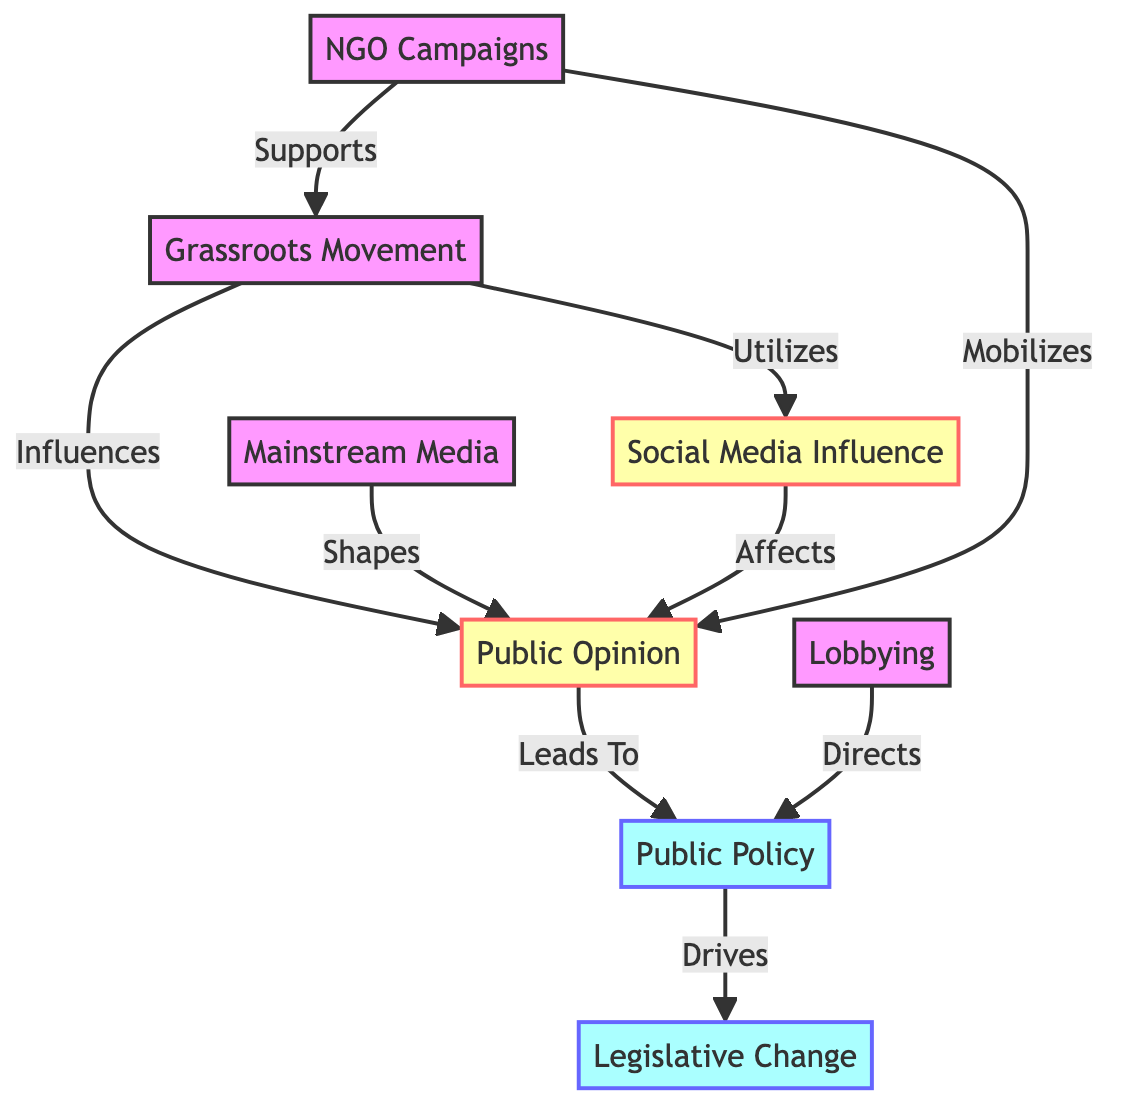What is the total number of nodes in the diagram? The diagram includes eight distinct nodes: Grassroots Movement, Mainstream Media, Social Media Influence, Public Opinion, Lobbying, Public Policy, Legislative Change, and NGO Campaigns. Counting these gives a total of eight nodes.
Answer: 8 Which node supports the grassroots movement? The diagram shows that NGO Campaigns supports the Grassroots Movement. The edge labeled "Supports" connects these two nodes.
Answer: NGO Campaigns What does public opinion lead to? The diagram indicates that Public Opinion leads to Public Policy, as represented by the edge labeled "Leads To" between these nodes.
Answer: Public Policy How many edges are present in the diagram? By examining the connections (edges) between the nodes, we count eight edges in total that connect the nodes in various ways.
Answer: 8 Which node influences public opinion? The diagram illustrates that Grassroots Movement influences Public Opinion, indicated by the edge labeled "Influences."
Answer: Grassroots Movement What is the relationship between public policy and legislative change? The diagram states that Public Policy drives Legislative Change, as depicted by the edge labeled "Drives."
Answer: Drives Which node utilizes social media influence? According to the diagram, the Grassroots Movement utilizes Social Media Influence, as shown by the edge labeled "Utilizes."
Answer: Grassroots Movement What mobilizes public opinion? The diagram shows that NGO Campaigns mobilize Public Opinion, as represented by the edge labeled "Mobilizes."
Answer: NGO Campaigns What shapes public opinion? The graphic indicates that Mainstream Media shapes Public Opinion, shown by the edge labeled "Shapes."
Answer: Mainstream Media 